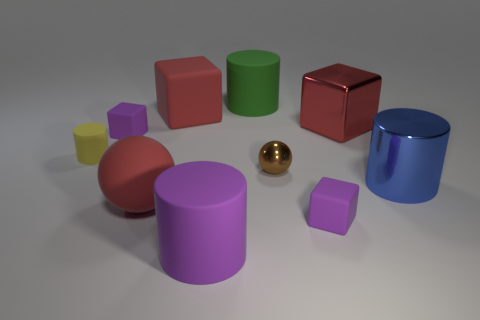Subtract all cyan cylinders. How many red blocks are left? 2 Subtract all yellow cylinders. How many cylinders are left? 3 Subtract all blue shiny cylinders. How many cylinders are left? 3 Subtract 1 blocks. How many blocks are left? 3 Subtract all brown blocks. Subtract all red cylinders. How many blocks are left? 4 Subtract all cubes. How many objects are left? 6 Subtract 0 cyan cylinders. How many objects are left? 10 Subtract all tiny brown metal balls. Subtract all matte cylinders. How many objects are left? 6 Add 8 brown spheres. How many brown spheres are left? 9 Add 3 tiny metal things. How many tiny metal things exist? 4 